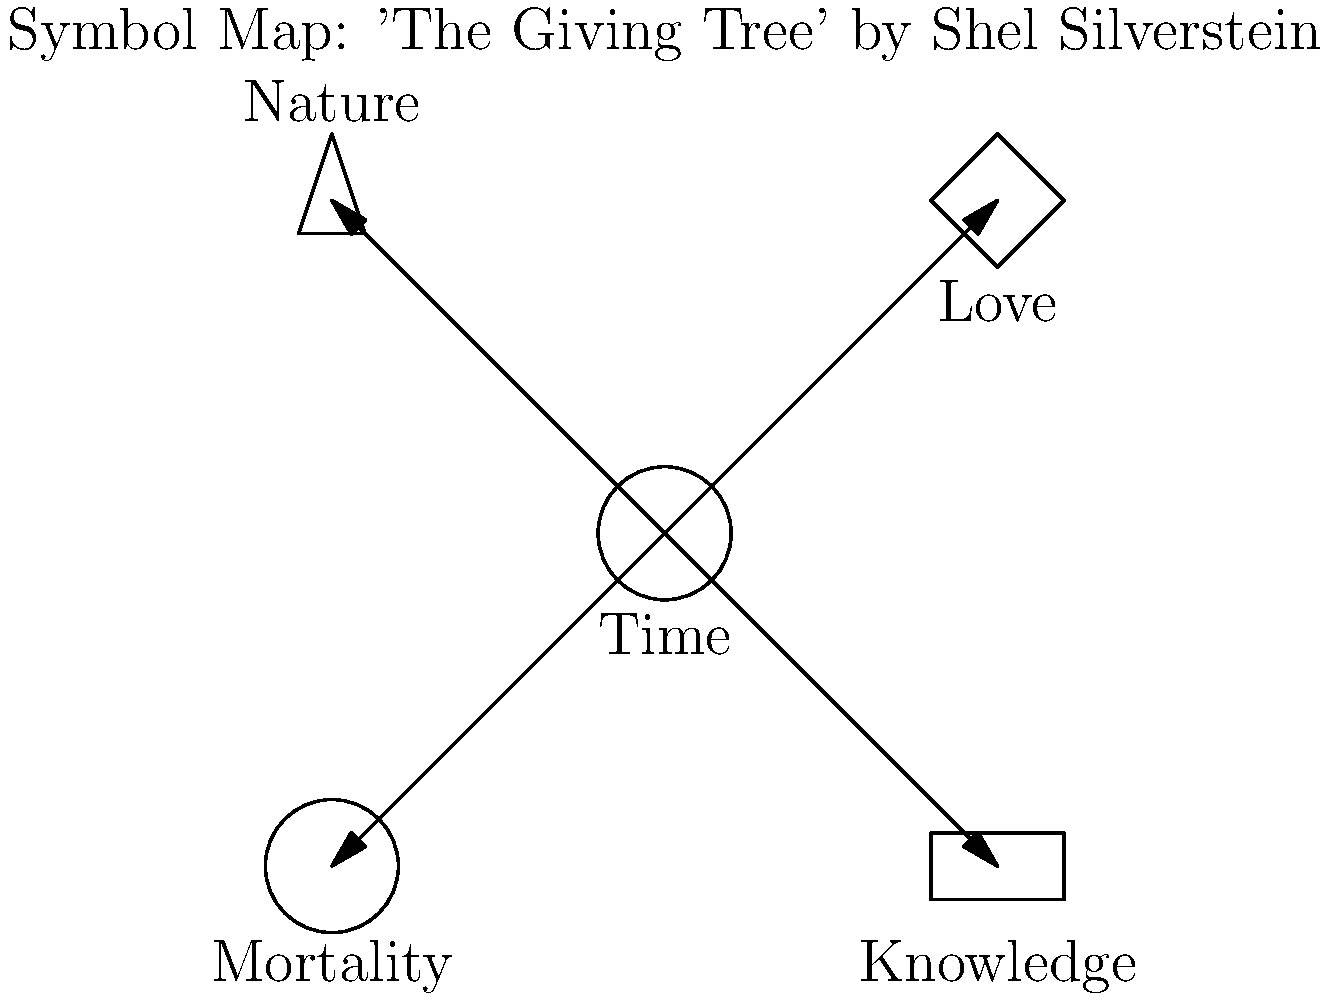Based on the symbol map provided for Shel Silverstein's "The Giving Tree," which theme appears to be most central to the story, connecting all other symbols? To answer this question, we need to analyze the symbol map and its connections:

1. The map shows five main symbols: Time, Love, Knowledge, Nature, and Mortality.
2. The central symbol in the map is "Time," represented by a clock.
3. All other symbols are connected to the central "Time" symbol with arrows pointing outward.
4. This arrangement suggests that Time is the core concept that links all other themes in the story.
5. In "The Giving Tree," the passage of time is indeed a crucial element that affects the relationship between the boy and the tree, showcasing changes in love, knowledge, nature, and mortality.
6. Time influences how the boy's love for the tree changes, how he gains knowledge and experiences, how nature (the tree) changes, and how both the boy and the tree face mortality.

Therefore, based on this visual representation, Time appears to be the most central theme connecting all other symbols in the story.
Answer: Time 